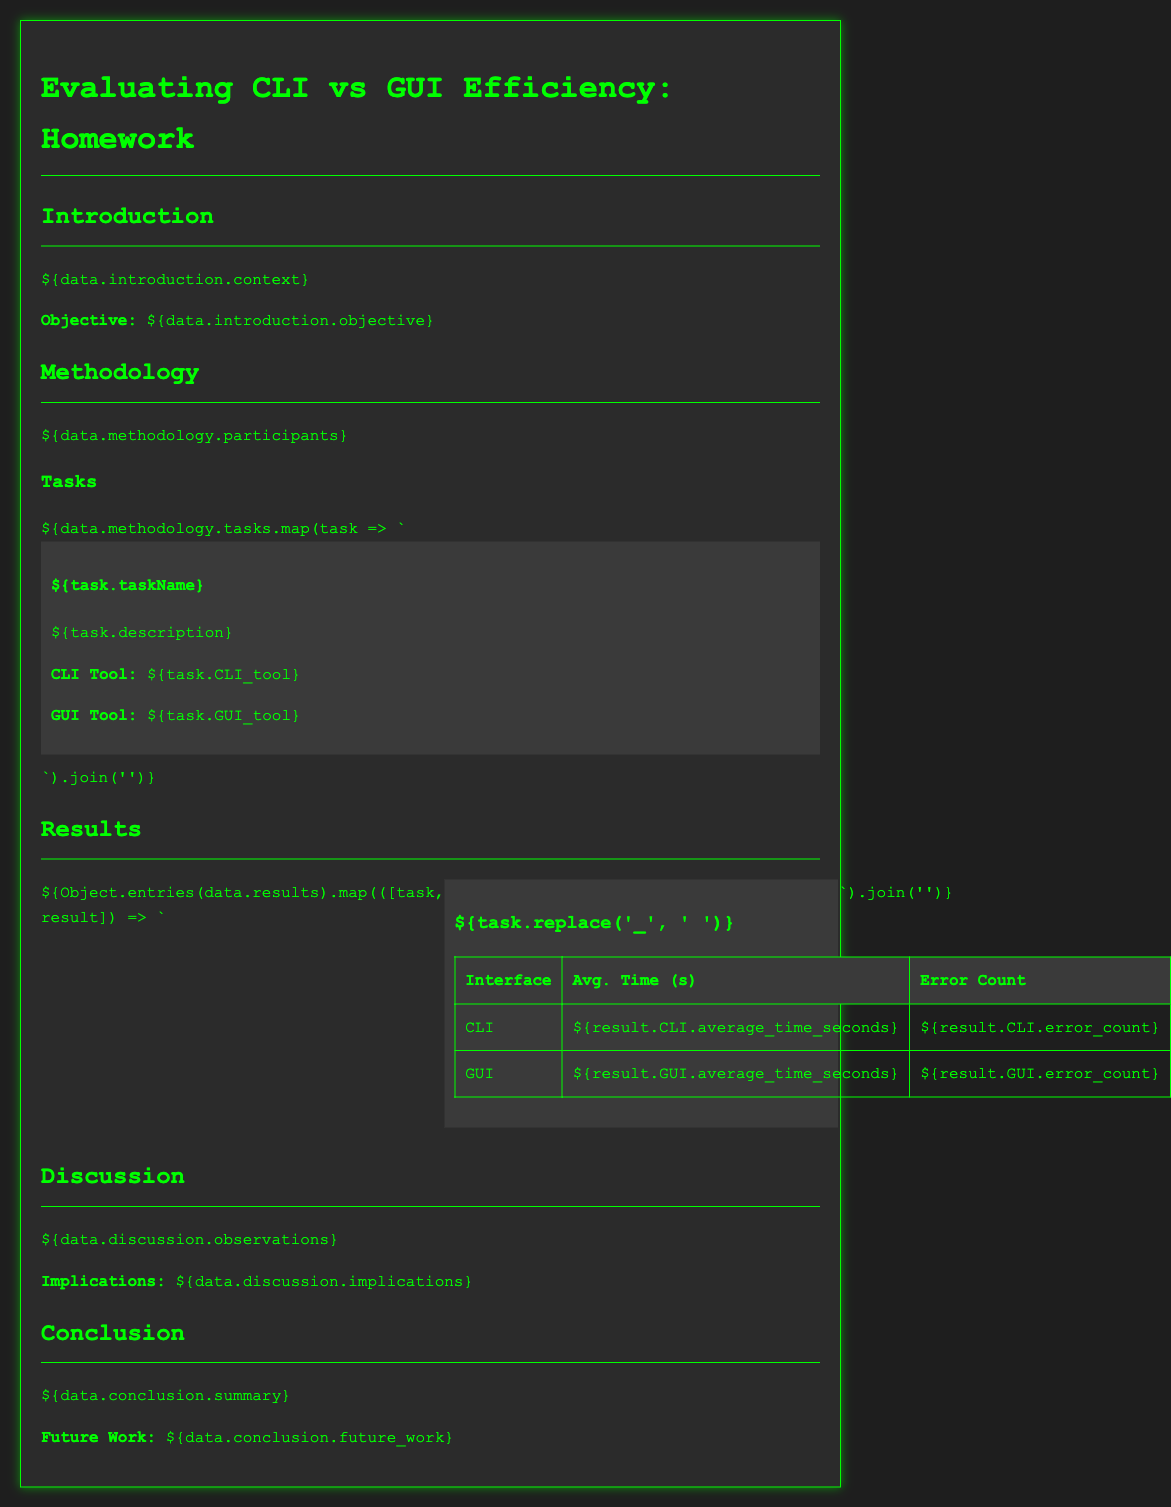What is the objective of the study? The objective is clearly stated in the introduction section of the document.
Answer: Efficiency evaluation of command-line interfaces versus GUIs How many participants were involved in the study? The methodology section lists the number of participants.
Answer: Not specified in the provided data Which CLI tool was used for the "File Manipulation" task? The task description specifies the tool used for each task.
Answer: CLI Tool Name What was the average time taken using the CLI for the "Data Processing" task? The results section contains average times for each interface and task.
Answer: Average Time Seconds What was the error count for the GUI in the "System Monitoring" task? The specific error count for each interface is mentioned in the results table.
Answer: Error Count What implications are discussed in the document? The implications are explained in the discussion section.
Answer: Implications Explanation What does the conclusion summarize? The conclusion section provides a summary of the findings.
Answer: Summary of findings What does the document discuss as future work? The future work section outlines areas for additional exploration.
Answer: Future Work Explanation 